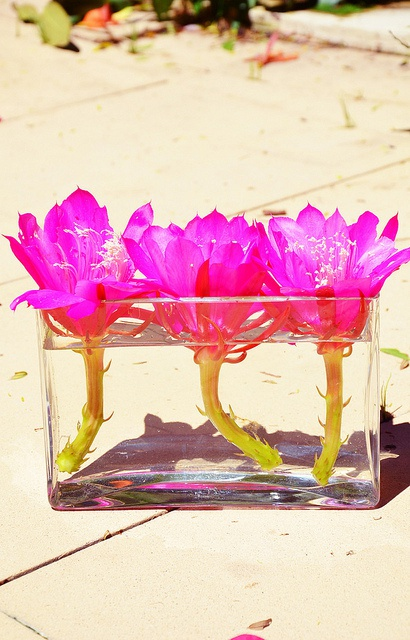Describe the objects in this image and their specific colors. I can see a vase in tan, beige, and brown tones in this image. 